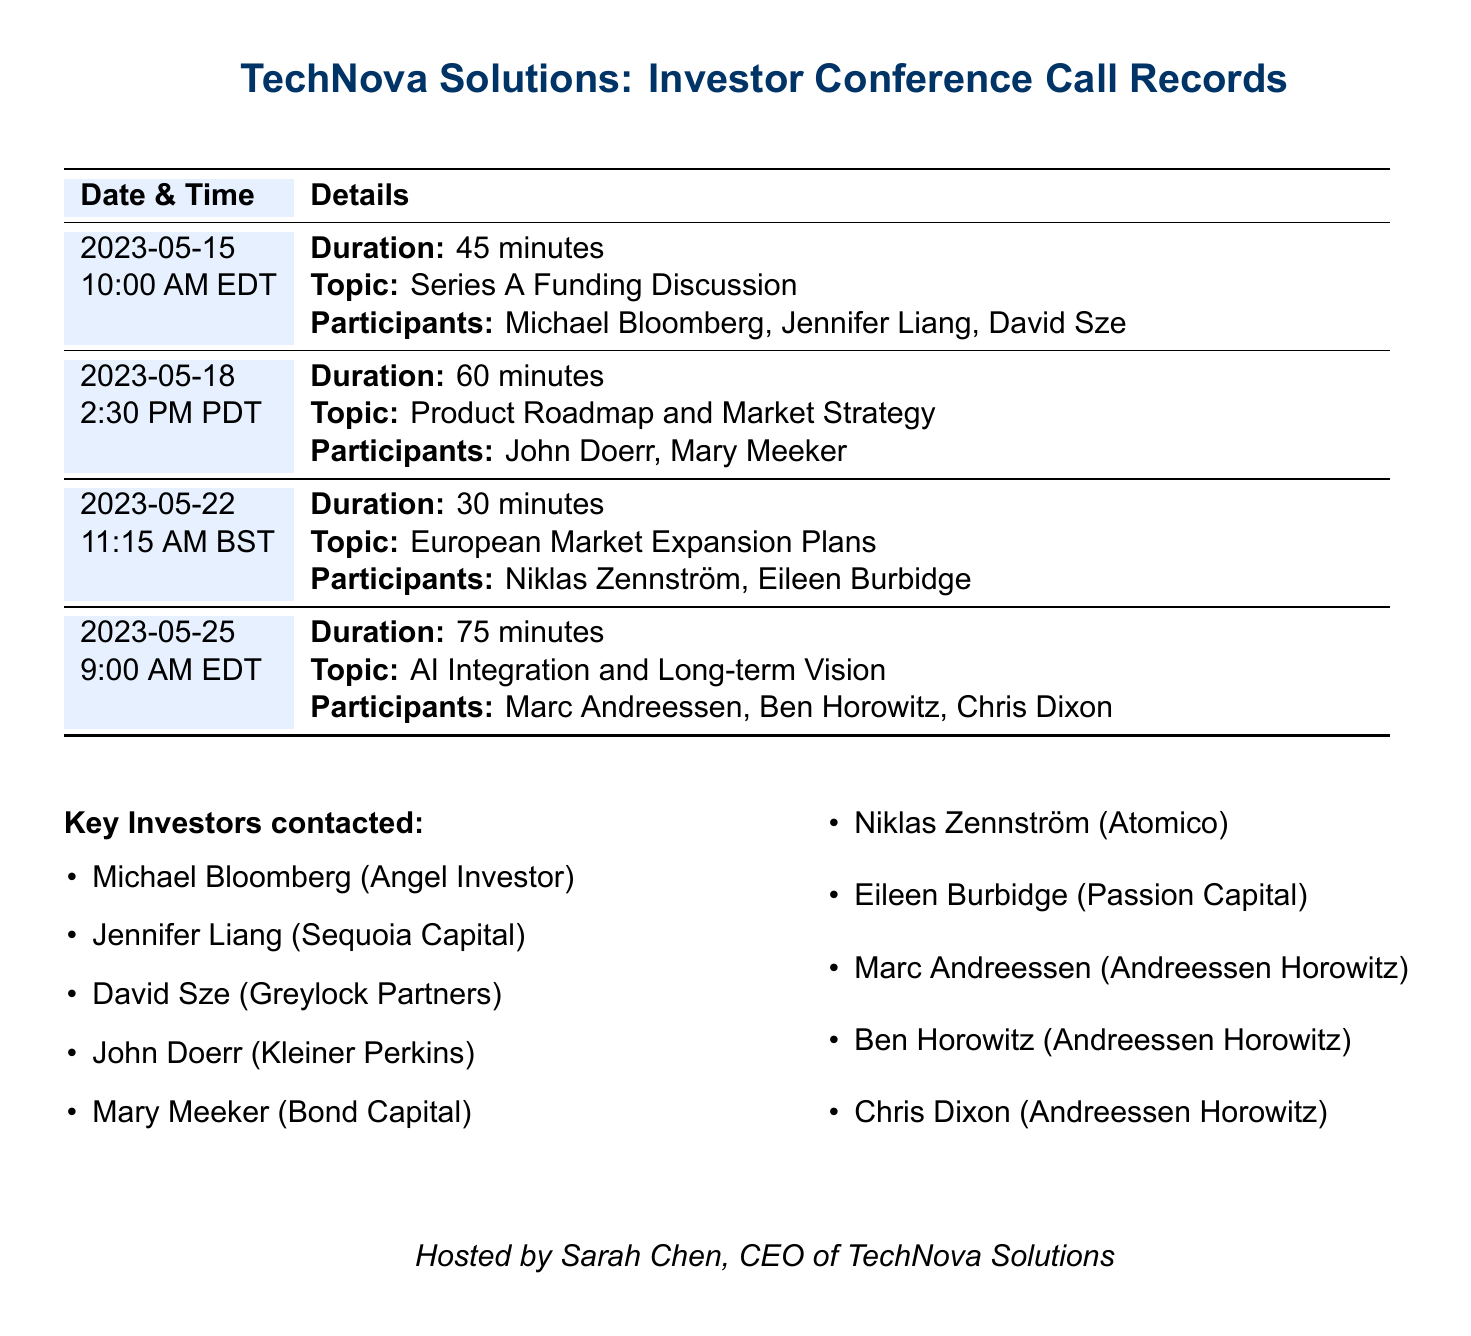What is the duration of the call on May 15, 2023? The duration of the call on May 15, 2023, is stated in the document as 45 minutes.
Answer: 45 minutes Who participated in the call on May 22, 2023? The participants of the call on May 22, 2023, are listed as Niklas Zennström and Eileen Burbidge.
Answer: Niklas Zennström, Eileen Burbidge What was the topic discussed during the call on May 25, 2023? The topic of the call on May 25, 2023, is explicitly mentioned as AI Integration and Long-term Vision.
Answer: AI Integration and Long-term Vision How many participants were involved in the call on May 18, 2023? The call on May 18, 2023, had two participants: John Doerr and Mary Meeker.
Answer: 2 Which companies are represented by Marc Andreessen and Ben Horowitz? The document mentions both Marc Andreessen and Ben Horowitz as participants from Andreessen Horowitz.
Answer: Andreessen Horowitz What is the total number of conference calls recorded? The document lists a total of four conference calls recorded.
Answer: 4 On what date and time did the call about Series A Funding take place? The document specifies that the Series A Funding Discussion occurred on May 15, 2023, at 10:00 AM EDT.
Answer: May 15, 2023, 10:00 AM EDT Who hosted the conference calls? The document states that Sarah Chen, CEO of TechNova Solutions, hosted the conference calls.
Answer: Sarah Chen 